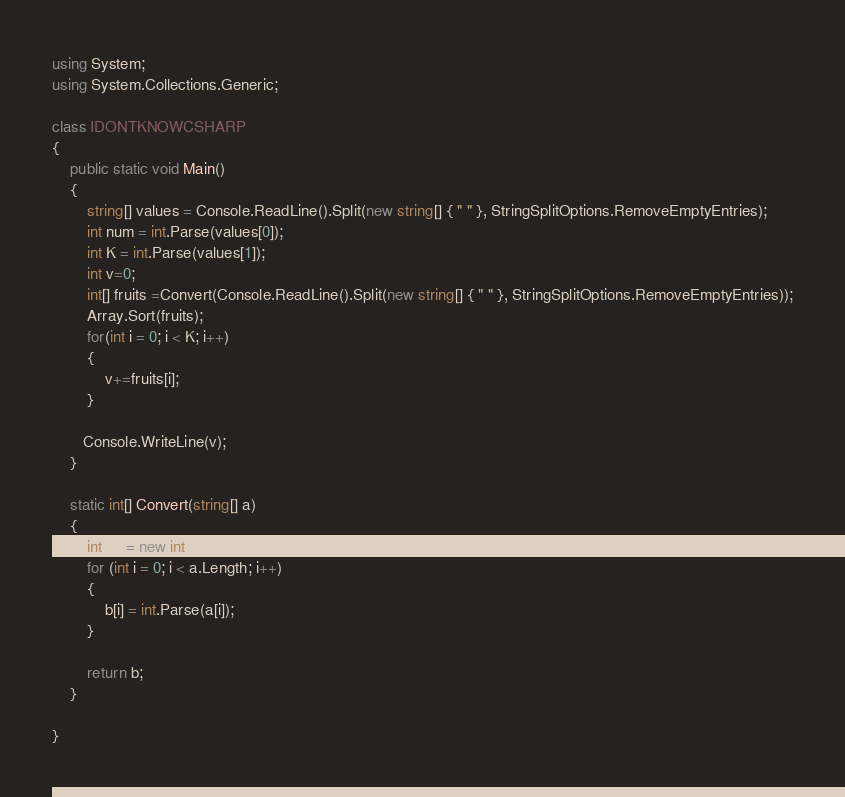<code> <loc_0><loc_0><loc_500><loc_500><_C#_>
using System;
using System.Collections.Generic;

class IDONTKNOWCSHARP
{
    public static void Main()
    {
        string[] values = Console.ReadLine().Split(new string[] { " " }, StringSplitOptions.RemoveEmptyEntries);
        int num = int.Parse(values[0]);
        int K = int.Parse(values[1]);
        int v=0;
        int[] fruits =Convert(Console.ReadLine().Split(new string[] { " " }, StringSplitOptions.RemoveEmptyEntries));
        Array.Sort(fruits);
        for(int i = 0; i < K; i++)
        {
            v+=fruits[i];
        }

       Console.WriteLine(v);
    }

    static int[] Convert(string[] a)
    {
        int[] b = new int[a.Length];
        for (int i = 0; i < a.Length; i++)
        {
            b[i] = int.Parse(a[i]);
        }

        return b;
    }

}</code> 